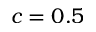<formula> <loc_0><loc_0><loc_500><loc_500>c = 0 . 5</formula> 